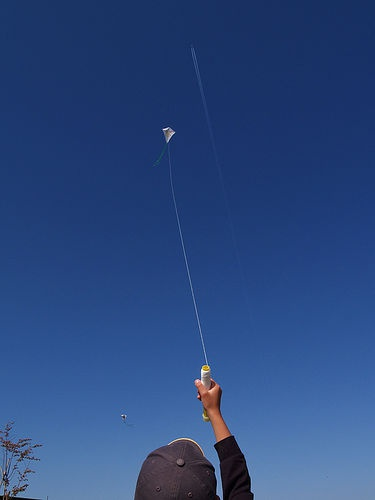Describe the objects in this image and their specific colors. I can see people in navy, black, purple, and brown tones, kite in navy, blue, and gray tones, and kite in navy, gray, blue, and black tones in this image. 